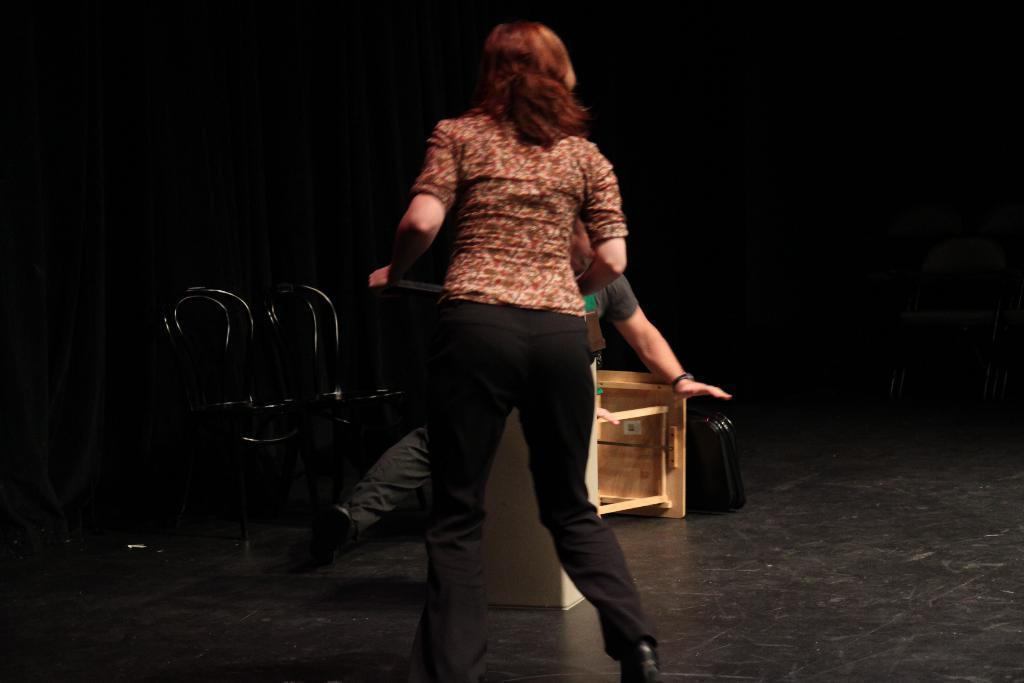How would you summarize this image in a sentence or two? In this image we can see a man and a woman on the floor. In that the woman is holding an object. We can also see some chairs, a table and an object which are placed on the surface. 